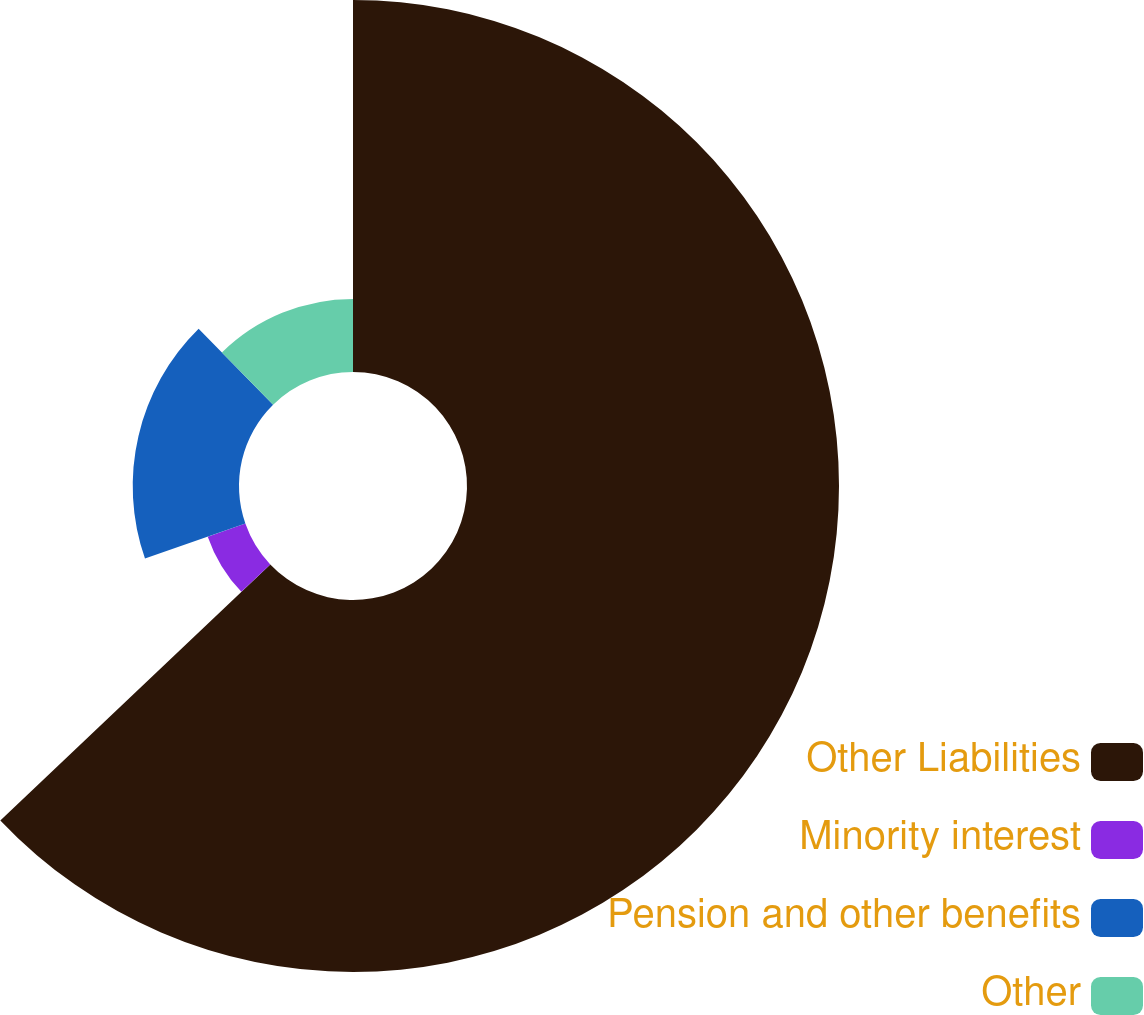Convert chart to OTSL. <chart><loc_0><loc_0><loc_500><loc_500><pie_chart><fcel>Other Liabilities<fcel>Minority interest<fcel>Pension and other benefits<fcel>Other<nl><fcel>62.93%<fcel>6.74%<fcel>17.98%<fcel>12.36%<nl></chart> 